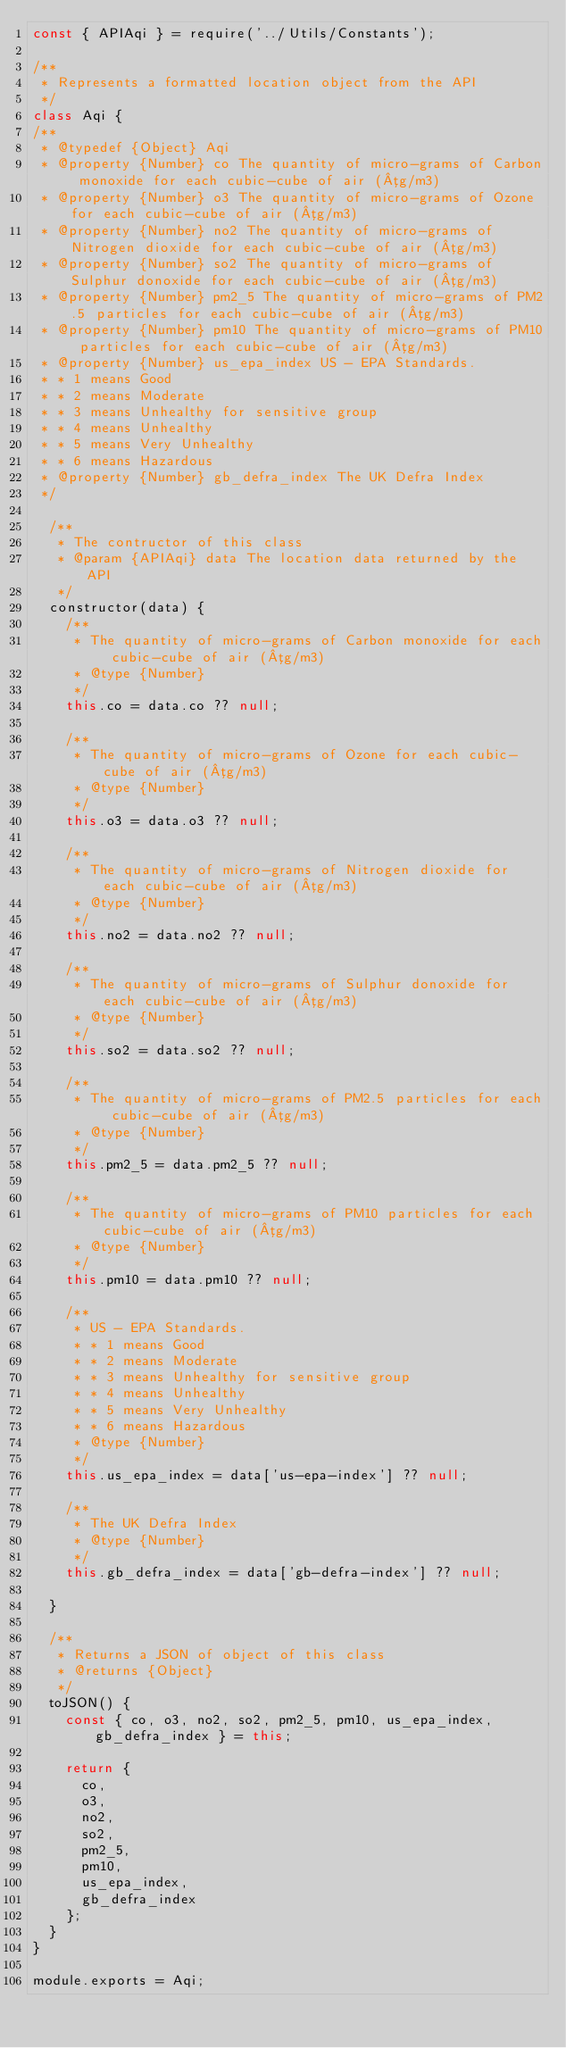Convert code to text. <code><loc_0><loc_0><loc_500><loc_500><_JavaScript_>const { APIAqi } = require('../Utils/Constants');

/**
 * Represents a formatted location object from the API 
 */
class Aqi {
/**
 * @typedef {Object} Aqi
 * @property {Number} co The quantity of micro-grams of Carbon monoxide for each cubic-cube of air (µg/m3)
 * @property {Number} o3 The quantity of micro-grams of Ozone for each cubic-cube of air (µg/m3)
 * @property {Number} no2 The quantity of micro-grams of Nitrogen dioxide for each cubic-cube of air (µg/m3)
 * @property {Number} so2 The quantity of micro-grams of Sulphur donoxide for each cubic-cube of air (µg/m3)
 * @property {Number} pm2_5 The quantity of micro-grams of PM2.5 particles for each cubic-cube of air (µg/m3)
 * @property {Number} pm10 The quantity of micro-grams of PM10 particles for each cubic-cube of air (µg/m3)
 * @property {Number} us_epa_index US - EPA Standards.
 * * 1 means Good
 * * 2 means Moderate
 * * 3 means Unhealthy for sensitive group
 * * 4 means Unhealthy
 * * 5 means Very Unhealthy
 * * 6 means Hazardous 
 * @property {Number} gb_defra_index The UK Defra Index
 */

  /**
   * The contructor of this class
   * @param {APIAqi} data The location data returned by the API
   */
  constructor(data) {
    /**
     * The quantity of micro-grams of Carbon monoxide for each cubic-cube of air (µg/m3)
     * @type {Number}
     */
    this.co = data.co ?? null;

    /**
     * The quantity of micro-grams of Ozone for each cubic-cube of air (µg/m3)
     * @type {Number}
     */
    this.o3 = data.o3 ?? null;

    /**
     * The quantity of micro-grams of Nitrogen dioxide for each cubic-cube of air (µg/m3)
     * @type {Number}
     */
    this.no2 = data.no2 ?? null;

    /**
     * The quantity of micro-grams of Sulphur donoxide for each cubic-cube of air (µg/m3)
     * @type {Number}
     */
    this.so2 = data.so2 ?? null;

    /**
     * The quantity of micro-grams of PM2.5 particles for each cubic-cube of air (µg/m3)
     * @type {Number}
     */
    this.pm2_5 = data.pm2_5 ?? null;

    /**
     * The quantity of micro-grams of PM10 particles for each cubic-cube of air (µg/m3)
     * @type {Number}
     */
    this.pm10 = data.pm10 ?? null;

    /**
     * US - EPA Standards.
     * * 1 means Good
     * * 2 means Moderate
     * * 3 means Unhealthy for sensitive group
     * * 4 means Unhealthy
     * * 5 means Very Unhealthy
     * * 6 means Hazardous
     * @type {Number} 
     */
    this.us_epa_index = data['us-epa-index'] ?? null;

    /**
     * The UK Defra Index
     * @type {Number}
     */
    this.gb_defra_index = data['gb-defra-index'] ?? null;
    
  }

  /**
   * Returns a JSON of object of this class
   * @returns {Object}
   */
  toJSON() {
    const { co, o3, no2, so2, pm2_5, pm10, us_epa_index, gb_defra_index } = this;

    return {
      co, 
      o3, 
      no2, 
      so2, 
      pm2_5, 
      pm10, 
      us_epa_index, 
      gb_defra_index
    };
  }
}

module.exports = Aqi;</code> 